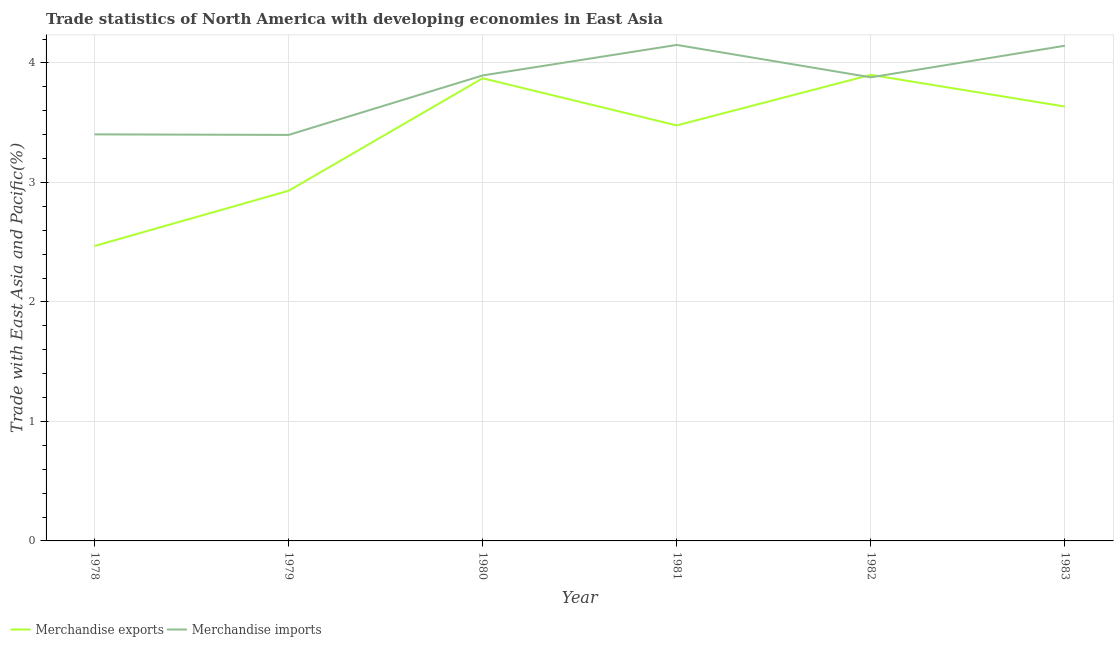How many different coloured lines are there?
Your answer should be compact. 2. Is the number of lines equal to the number of legend labels?
Make the answer very short. Yes. What is the merchandise exports in 1979?
Offer a terse response. 2.93. Across all years, what is the maximum merchandise imports?
Ensure brevity in your answer.  4.15. Across all years, what is the minimum merchandise exports?
Provide a short and direct response. 2.47. In which year was the merchandise exports minimum?
Offer a terse response. 1978. What is the total merchandise exports in the graph?
Offer a very short reply. 20.28. What is the difference between the merchandise exports in 1979 and that in 1983?
Provide a short and direct response. -0.7. What is the difference between the merchandise imports in 1980 and the merchandise exports in 1983?
Offer a terse response. 0.26. What is the average merchandise exports per year?
Provide a succinct answer. 3.38. In the year 1979, what is the difference between the merchandise exports and merchandise imports?
Keep it short and to the point. -0.47. What is the ratio of the merchandise imports in 1979 to that in 1981?
Keep it short and to the point. 0.82. Is the merchandise imports in 1978 less than that in 1981?
Provide a short and direct response. Yes. What is the difference between the highest and the second highest merchandise imports?
Offer a terse response. 0.01. What is the difference between the highest and the lowest merchandise imports?
Your answer should be very brief. 0.75. In how many years, is the merchandise imports greater than the average merchandise imports taken over all years?
Your answer should be very brief. 4. Does the merchandise imports monotonically increase over the years?
Ensure brevity in your answer.  No. How many lines are there?
Give a very brief answer. 2. How many years are there in the graph?
Your answer should be compact. 6. Are the values on the major ticks of Y-axis written in scientific E-notation?
Give a very brief answer. No. Does the graph contain any zero values?
Offer a terse response. No. How many legend labels are there?
Give a very brief answer. 2. How are the legend labels stacked?
Your response must be concise. Horizontal. What is the title of the graph?
Offer a very short reply. Trade statistics of North America with developing economies in East Asia. What is the label or title of the Y-axis?
Provide a short and direct response. Trade with East Asia and Pacific(%). What is the Trade with East Asia and Pacific(%) in Merchandise exports in 1978?
Give a very brief answer. 2.47. What is the Trade with East Asia and Pacific(%) in Merchandise imports in 1978?
Provide a succinct answer. 3.4. What is the Trade with East Asia and Pacific(%) of Merchandise exports in 1979?
Provide a succinct answer. 2.93. What is the Trade with East Asia and Pacific(%) in Merchandise imports in 1979?
Offer a terse response. 3.4. What is the Trade with East Asia and Pacific(%) of Merchandise exports in 1980?
Provide a short and direct response. 3.87. What is the Trade with East Asia and Pacific(%) of Merchandise imports in 1980?
Your answer should be very brief. 3.9. What is the Trade with East Asia and Pacific(%) of Merchandise exports in 1981?
Offer a terse response. 3.48. What is the Trade with East Asia and Pacific(%) in Merchandise imports in 1981?
Offer a terse response. 4.15. What is the Trade with East Asia and Pacific(%) of Merchandise exports in 1982?
Offer a very short reply. 3.9. What is the Trade with East Asia and Pacific(%) in Merchandise imports in 1982?
Your response must be concise. 3.88. What is the Trade with East Asia and Pacific(%) of Merchandise exports in 1983?
Give a very brief answer. 3.63. What is the Trade with East Asia and Pacific(%) of Merchandise imports in 1983?
Offer a very short reply. 4.14. Across all years, what is the maximum Trade with East Asia and Pacific(%) in Merchandise exports?
Ensure brevity in your answer.  3.9. Across all years, what is the maximum Trade with East Asia and Pacific(%) in Merchandise imports?
Offer a terse response. 4.15. Across all years, what is the minimum Trade with East Asia and Pacific(%) of Merchandise exports?
Offer a terse response. 2.47. Across all years, what is the minimum Trade with East Asia and Pacific(%) of Merchandise imports?
Make the answer very short. 3.4. What is the total Trade with East Asia and Pacific(%) of Merchandise exports in the graph?
Provide a short and direct response. 20.28. What is the total Trade with East Asia and Pacific(%) of Merchandise imports in the graph?
Provide a short and direct response. 22.87. What is the difference between the Trade with East Asia and Pacific(%) of Merchandise exports in 1978 and that in 1979?
Ensure brevity in your answer.  -0.46. What is the difference between the Trade with East Asia and Pacific(%) in Merchandise imports in 1978 and that in 1979?
Keep it short and to the point. 0. What is the difference between the Trade with East Asia and Pacific(%) in Merchandise exports in 1978 and that in 1980?
Ensure brevity in your answer.  -1.4. What is the difference between the Trade with East Asia and Pacific(%) in Merchandise imports in 1978 and that in 1980?
Ensure brevity in your answer.  -0.49. What is the difference between the Trade with East Asia and Pacific(%) of Merchandise exports in 1978 and that in 1981?
Make the answer very short. -1.01. What is the difference between the Trade with East Asia and Pacific(%) of Merchandise imports in 1978 and that in 1981?
Provide a succinct answer. -0.75. What is the difference between the Trade with East Asia and Pacific(%) in Merchandise exports in 1978 and that in 1982?
Keep it short and to the point. -1.43. What is the difference between the Trade with East Asia and Pacific(%) of Merchandise imports in 1978 and that in 1982?
Provide a succinct answer. -0.48. What is the difference between the Trade with East Asia and Pacific(%) in Merchandise exports in 1978 and that in 1983?
Give a very brief answer. -1.17. What is the difference between the Trade with East Asia and Pacific(%) of Merchandise imports in 1978 and that in 1983?
Provide a short and direct response. -0.74. What is the difference between the Trade with East Asia and Pacific(%) of Merchandise exports in 1979 and that in 1980?
Offer a very short reply. -0.94. What is the difference between the Trade with East Asia and Pacific(%) in Merchandise imports in 1979 and that in 1980?
Offer a terse response. -0.5. What is the difference between the Trade with East Asia and Pacific(%) in Merchandise exports in 1979 and that in 1981?
Offer a very short reply. -0.55. What is the difference between the Trade with East Asia and Pacific(%) of Merchandise imports in 1979 and that in 1981?
Make the answer very short. -0.75. What is the difference between the Trade with East Asia and Pacific(%) of Merchandise exports in 1979 and that in 1982?
Your answer should be very brief. -0.97. What is the difference between the Trade with East Asia and Pacific(%) of Merchandise imports in 1979 and that in 1982?
Give a very brief answer. -0.48. What is the difference between the Trade with East Asia and Pacific(%) of Merchandise exports in 1979 and that in 1983?
Make the answer very short. -0.7. What is the difference between the Trade with East Asia and Pacific(%) in Merchandise imports in 1979 and that in 1983?
Keep it short and to the point. -0.75. What is the difference between the Trade with East Asia and Pacific(%) of Merchandise exports in 1980 and that in 1981?
Provide a succinct answer. 0.39. What is the difference between the Trade with East Asia and Pacific(%) in Merchandise imports in 1980 and that in 1981?
Ensure brevity in your answer.  -0.26. What is the difference between the Trade with East Asia and Pacific(%) of Merchandise exports in 1980 and that in 1982?
Offer a terse response. -0.03. What is the difference between the Trade with East Asia and Pacific(%) of Merchandise imports in 1980 and that in 1982?
Offer a very short reply. 0.02. What is the difference between the Trade with East Asia and Pacific(%) of Merchandise exports in 1980 and that in 1983?
Your response must be concise. 0.24. What is the difference between the Trade with East Asia and Pacific(%) of Merchandise imports in 1980 and that in 1983?
Provide a succinct answer. -0.25. What is the difference between the Trade with East Asia and Pacific(%) of Merchandise exports in 1981 and that in 1982?
Make the answer very short. -0.42. What is the difference between the Trade with East Asia and Pacific(%) in Merchandise imports in 1981 and that in 1982?
Keep it short and to the point. 0.27. What is the difference between the Trade with East Asia and Pacific(%) in Merchandise exports in 1981 and that in 1983?
Ensure brevity in your answer.  -0.16. What is the difference between the Trade with East Asia and Pacific(%) in Merchandise imports in 1981 and that in 1983?
Give a very brief answer. 0.01. What is the difference between the Trade with East Asia and Pacific(%) in Merchandise exports in 1982 and that in 1983?
Your response must be concise. 0.27. What is the difference between the Trade with East Asia and Pacific(%) in Merchandise imports in 1982 and that in 1983?
Make the answer very short. -0.26. What is the difference between the Trade with East Asia and Pacific(%) of Merchandise exports in 1978 and the Trade with East Asia and Pacific(%) of Merchandise imports in 1979?
Your response must be concise. -0.93. What is the difference between the Trade with East Asia and Pacific(%) in Merchandise exports in 1978 and the Trade with East Asia and Pacific(%) in Merchandise imports in 1980?
Give a very brief answer. -1.43. What is the difference between the Trade with East Asia and Pacific(%) in Merchandise exports in 1978 and the Trade with East Asia and Pacific(%) in Merchandise imports in 1981?
Provide a short and direct response. -1.68. What is the difference between the Trade with East Asia and Pacific(%) of Merchandise exports in 1978 and the Trade with East Asia and Pacific(%) of Merchandise imports in 1982?
Give a very brief answer. -1.41. What is the difference between the Trade with East Asia and Pacific(%) in Merchandise exports in 1978 and the Trade with East Asia and Pacific(%) in Merchandise imports in 1983?
Keep it short and to the point. -1.68. What is the difference between the Trade with East Asia and Pacific(%) in Merchandise exports in 1979 and the Trade with East Asia and Pacific(%) in Merchandise imports in 1980?
Your answer should be compact. -0.97. What is the difference between the Trade with East Asia and Pacific(%) in Merchandise exports in 1979 and the Trade with East Asia and Pacific(%) in Merchandise imports in 1981?
Give a very brief answer. -1.22. What is the difference between the Trade with East Asia and Pacific(%) in Merchandise exports in 1979 and the Trade with East Asia and Pacific(%) in Merchandise imports in 1982?
Give a very brief answer. -0.95. What is the difference between the Trade with East Asia and Pacific(%) in Merchandise exports in 1979 and the Trade with East Asia and Pacific(%) in Merchandise imports in 1983?
Provide a short and direct response. -1.21. What is the difference between the Trade with East Asia and Pacific(%) of Merchandise exports in 1980 and the Trade with East Asia and Pacific(%) of Merchandise imports in 1981?
Offer a very short reply. -0.28. What is the difference between the Trade with East Asia and Pacific(%) of Merchandise exports in 1980 and the Trade with East Asia and Pacific(%) of Merchandise imports in 1982?
Give a very brief answer. -0.01. What is the difference between the Trade with East Asia and Pacific(%) of Merchandise exports in 1980 and the Trade with East Asia and Pacific(%) of Merchandise imports in 1983?
Keep it short and to the point. -0.27. What is the difference between the Trade with East Asia and Pacific(%) of Merchandise exports in 1981 and the Trade with East Asia and Pacific(%) of Merchandise imports in 1982?
Offer a terse response. -0.4. What is the difference between the Trade with East Asia and Pacific(%) of Merchandise exports in 1981 and the Trade with East Asia and Pacific(%) of Merchandise imports in 1983?
Keep it short and to the point. -0.67. What is the difference between the Trade with East Asia and Pacific(%) in Merchandise exports in 1982 and the Trade with East Asia and Pacific(%) in Merchandise imports in 1983?
Your answer should be compact. -0.24. What is the average Trade with East Asia and Pacific(%) of Merchandise exports per year?
Offer a terse response. 3.38. What is the average Trade with East Asia and Pacific(%) in Merchandise imports per year?
Offer a very short reply. 3.81. In the year 1978, what is the difference between the Trade with East Asia and Pacific(%) in Merchandise exports and Trade with East Asia and Pacific(%) in Merchandise imports?
Give a very brief answer. -0.93. In the year 1979, what is the difference between the Trade with East Asia and Pacific(%) in Merchandise exports and Trade with East Asia and Pacific(%) in Merchandise imports?
Provide a short and direct response. -0.47. In the year 1980, what is the difference between the Trade with East Asia and Pacific(%) in Merchandise exports and Trade with East Asia and Pacific(%) in Merchandise imports?
Ensure brevity in your answer.  -0.02. In the year 1981, what is the difference between the Trade with East Asia and Pacific(%) in Merchandise exports and Trade with East Asia and Pacific(%) in Merchandise imports?
Provide a succinct answer. -0.67. In the year 1982, what is the difference between the Trade with East Asia and Pacific(%) in Merchandise exports and Trade with East Asia and Pacific(%) in Merchandise imports?
Keep it short and to the point. 0.02. In the year 1983, what is the difference between the Trade with East Asia and Pacific(%) of Merchandise exports and Trade with East Asia and Pacific(%) of Merchandise imports?
Give a very brief answer. -0.51. What is the ratio of the Trade with East Asia and Pacific(%) in Merchandise exports in 1978 to that in 1979?
Your answer should be very brief. 0.84. What is the ratio of the Trade with East Asia and Pacific(%) in Merchandise imports in 1978 to that in 1979?
Your answer should be very brief. 1. What is the ratio of the Trade with East Asia and Pacific(%) of Merchandise exports in 1978 to that in 1980?
Your answer should be compact. 0.64. What is the ratio of the Trade with East Asia and Pacific(%) in Merchandise imports in 1978 to that in 1980?
Provide a short and direct response. 0.87. What is the ratio of the Trade with East Asia and Pacific(%) in Merchandise exports in 1978 to that in 1981?
Your answer should be very brief. 0.71. What is the ratio of the Trade with East Asia and Pacific(%) of Merchandise imports in 1978 to that in 1981?
Ensure brevity in your answer.  0.82. What is the ratio of the Trade with East Asia and Pacific(%) of Merchandise exports in 1978 to that in 1982?
Provide a short and direct response. 0.63. What is the ratio of the Trade with East Asia and Pacific(%) of Merchandise imports in 1978 to that in 1982?
Offer a terse response. 0.88. What is the ratio of the Trade with East Asia and Pacific(%) in Merchandise exports in 1978 to that in 1983?
Offer a very short reply. 0.68. What is the ratio of the Trade with East Asia and Pacific(%) in Merchandise imports in 1978 to that in 1983?
Offer a terse response. 0.82. What is the ratio of the Trade with East Asia and Pacific(%) in Merchandise exports in 1979 to that in 1980?
Keep it short and to the point. 0.76. What is the ratio of the Trade with East Asia and Pacific(%) in Merchandise imports in 1979 to that in 1980?
Make the answer very short. 0.87. What is the ratio of the Trade with East Asia and Pacific(%) of Merchandise exports in 1979 to that in 1981?
Ensure brevity in your answer.  0.84. What is the ratio of the Trade with East Asia and Pacific(%) of Merchandise imports in 1979 to that in 1981?
Your answer should be very brief. 0.82. What is the ratio of the Trade with East Asia and Pacific(%) of Merchandise exports in 1979 to that in 1982?
Give a very brief answer. 0.75. What is the ratio of the Trade with East Asia and Pacific(%) in Merchandise imports in 1979 to that in 1982?
Offer a very short reply. 0.88. What is the ratio of the Trade with East Asia and Pacific(%) in Merchandise exports in 1979 to that in 1983?
Provide a short and direct response. 0.81. What is the ratio of the Trade with East Asia and Pacific(%) of Merchandise imports in 1979 to that in 1983?
Give a very brief answer. 0.82. What is the ratio of the Trade with East Asia and Pacific(%) in Merchandise exports in 1980 to that in 1981?
Ensure brevity in your answer.  1.11. What is the ratio of the Trade with East Asia and Pacific(%) in Merchandise imports in 1980 to that in 1981?
Make the answer very short. 0.94. What is the ratio of the Trade with East Asia and Pacific(%) in Merchandise exports in 1980 to that in 1982?
Provide a short and direct response. 0.99. What is the ratio of the Trade with East Asia and Pacific(%) in Merchandise exports in 1980 to that in 1983?
Keep it short and to the point. 1.07. What is the ratio of the Trade with East Asia and Pacific(%) of Merchandise exports in 1981 to that in 1982?
Keep it short and to the point. 0.89. What is the ratio of the Trade with East Asia and Pacific(%) of Merchandise imports in 1981 to that in 1982?
Provide a short and direct response. 1.07. What is the ratio of the Trade with East Asia and Pacific(%) in Merchandise exports in 1981 to that in 1983?
Provide a succinct answer. 0.96. What is the ratio of the Trade with East Asia and Pacific(%) in Merchandise exports in 1982 to that in 1983?
Make the answer very short. 1.07. What is the ratio of the Trade with East Asia and Pacific(%) in Merchandise imports in 1982 to that in 1983?
Provide a succinct answer. 0.94. What is the difference between the highest and the second highest Trade with East Asia and Pacific(%) in Merchandise exports?
Keep it short and to the point. 0.03. What is the difference between the highest and the second highest Trade with East Asia and Pacific(%) in Merchandise imports?
Make the answer very short. 0.01. What is the difference between the highest and the lowest Trade with East Asia and Pacific(%) in Merchandise exports?
Ensure brevity in your answer.  1.43. What is the difference between the highest and the lowest Trade with East Asia and Pacific(%) in Merchandise imports?
Ensure brevity in your answer.  0.75. 